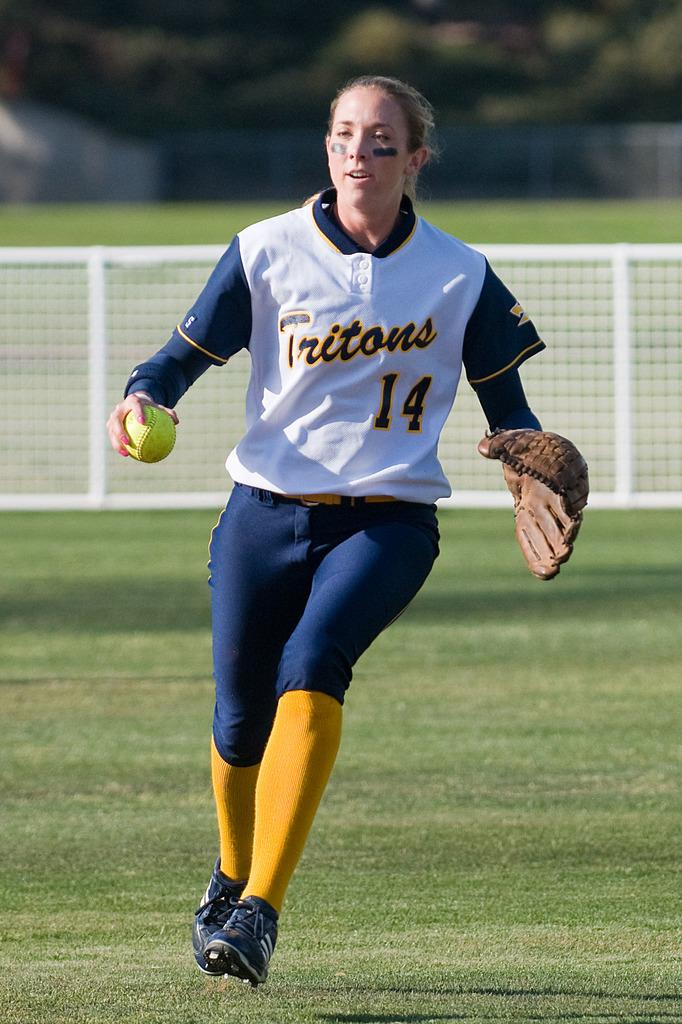<image>
Summarize the visual content of the image. A woman wearing a Tritons jersey with the number 14 is holding onto a softball. 